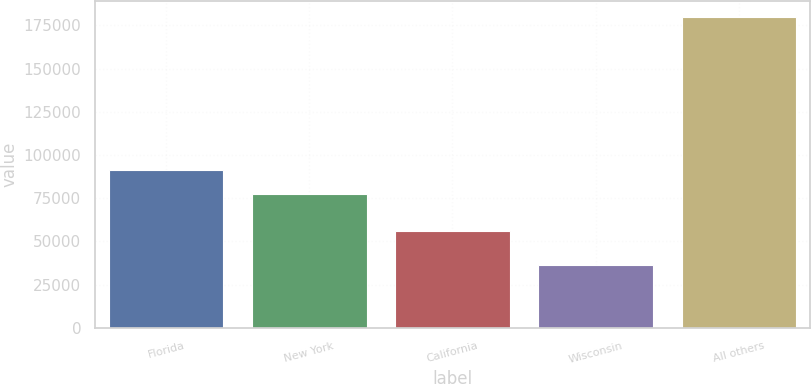Convert chart. <chart><loc_0><loc_0><loc_500><loc_500><bar_chart><fcel>Florida<fcel>New York<fcel>California<fcel>Wisconsin<fcel>All others<nl><fcel>91591.4<fcel>77210<fcel>55740<fcel>36193<fcel>180007<nl></chart> 